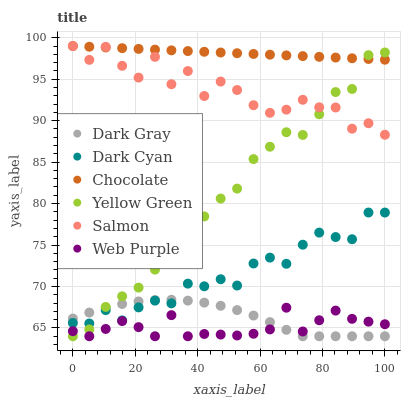Does Web Purple have the minimum area under the curve?
Answer yes or no. Yes. Does Chocolate have the maximum area under the curve?
Answer yes or no. Yes. Does Salmon have the minimum area under the curve?
Answer yes or no. No. Does Salmon have the maximum area under the curve?
Answer yes or no. No. Is Chocolate the smoothest?
Answer yes or no. Yes. Is Salmon the roughest?
Answer yes or no. Yes. Is Salmon the smoothest?
Answer yes or no. No. Is Chocolate the roughest?
Answer yes or no. No. Does Yellow Green have the lowest value?
Answer yes or no. Yes. Does Salmon have the lowest value?
Answer yes or no. No. Does Chocolate have the highest value?
Answer yes or no. Yes. Does Dark Gray have the highest value?
Answer yes or no. No. Is Dark Gray less than Chocolate?
Answer yes or no. Yes. Is Salmon greater than Web Purple?
Answer yes or no. Yes. Does Web Purple intersect Yellow Green?
Answer yes or no. Yes. Is Web Purple less than Yellow Green?
Answer yes or no. No. Is Web Purple greater than Yellow Green?
Answer yes or no. No. Does Dark Gray intersect Chocolate?
Answer yes or no. No. 